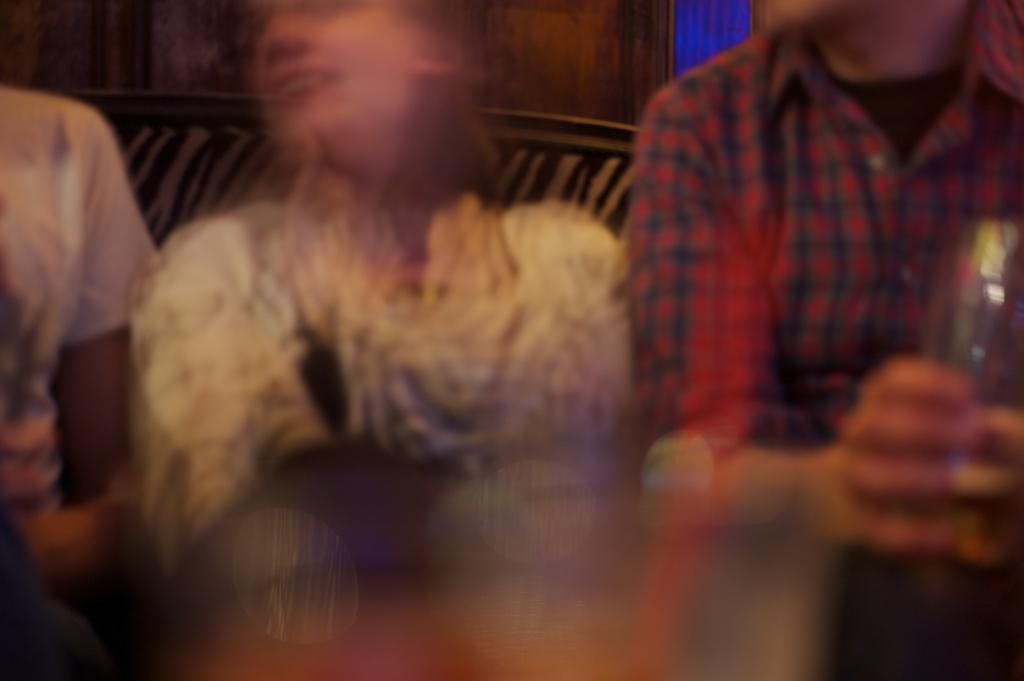How many people are in the image? There are three persons in the image. What are the persons doing in the image? The persons are sitting on a couch. What can be seen in the background of the image? There is a wall in the background of the image. How many beds are visible in the image? There are no beds visible in the image; it features three persons sitting on a couch. What type of sock is the person on the left wearing in the image? There is no sock visible on any person in the image. 